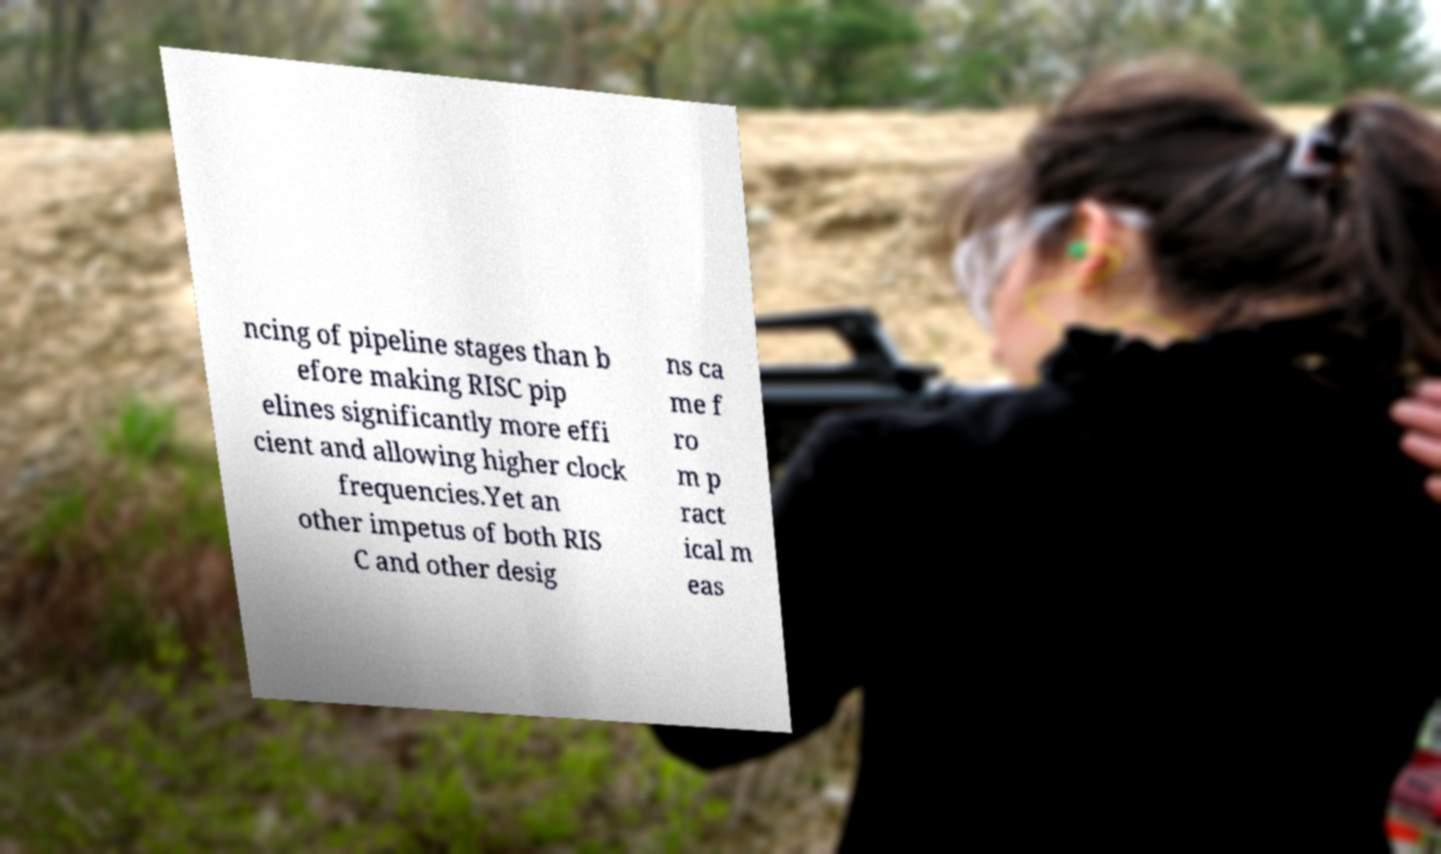What messages or text are displayed in this image? I need them in a readable, typed format. ncing of pipeline stages than b efore making RISC pip elines significantly more effi cient and allowing higher clock frequencies.Yet an other impetus of both RIS C and other desig ns ca me f ro m p ract ical m eas 